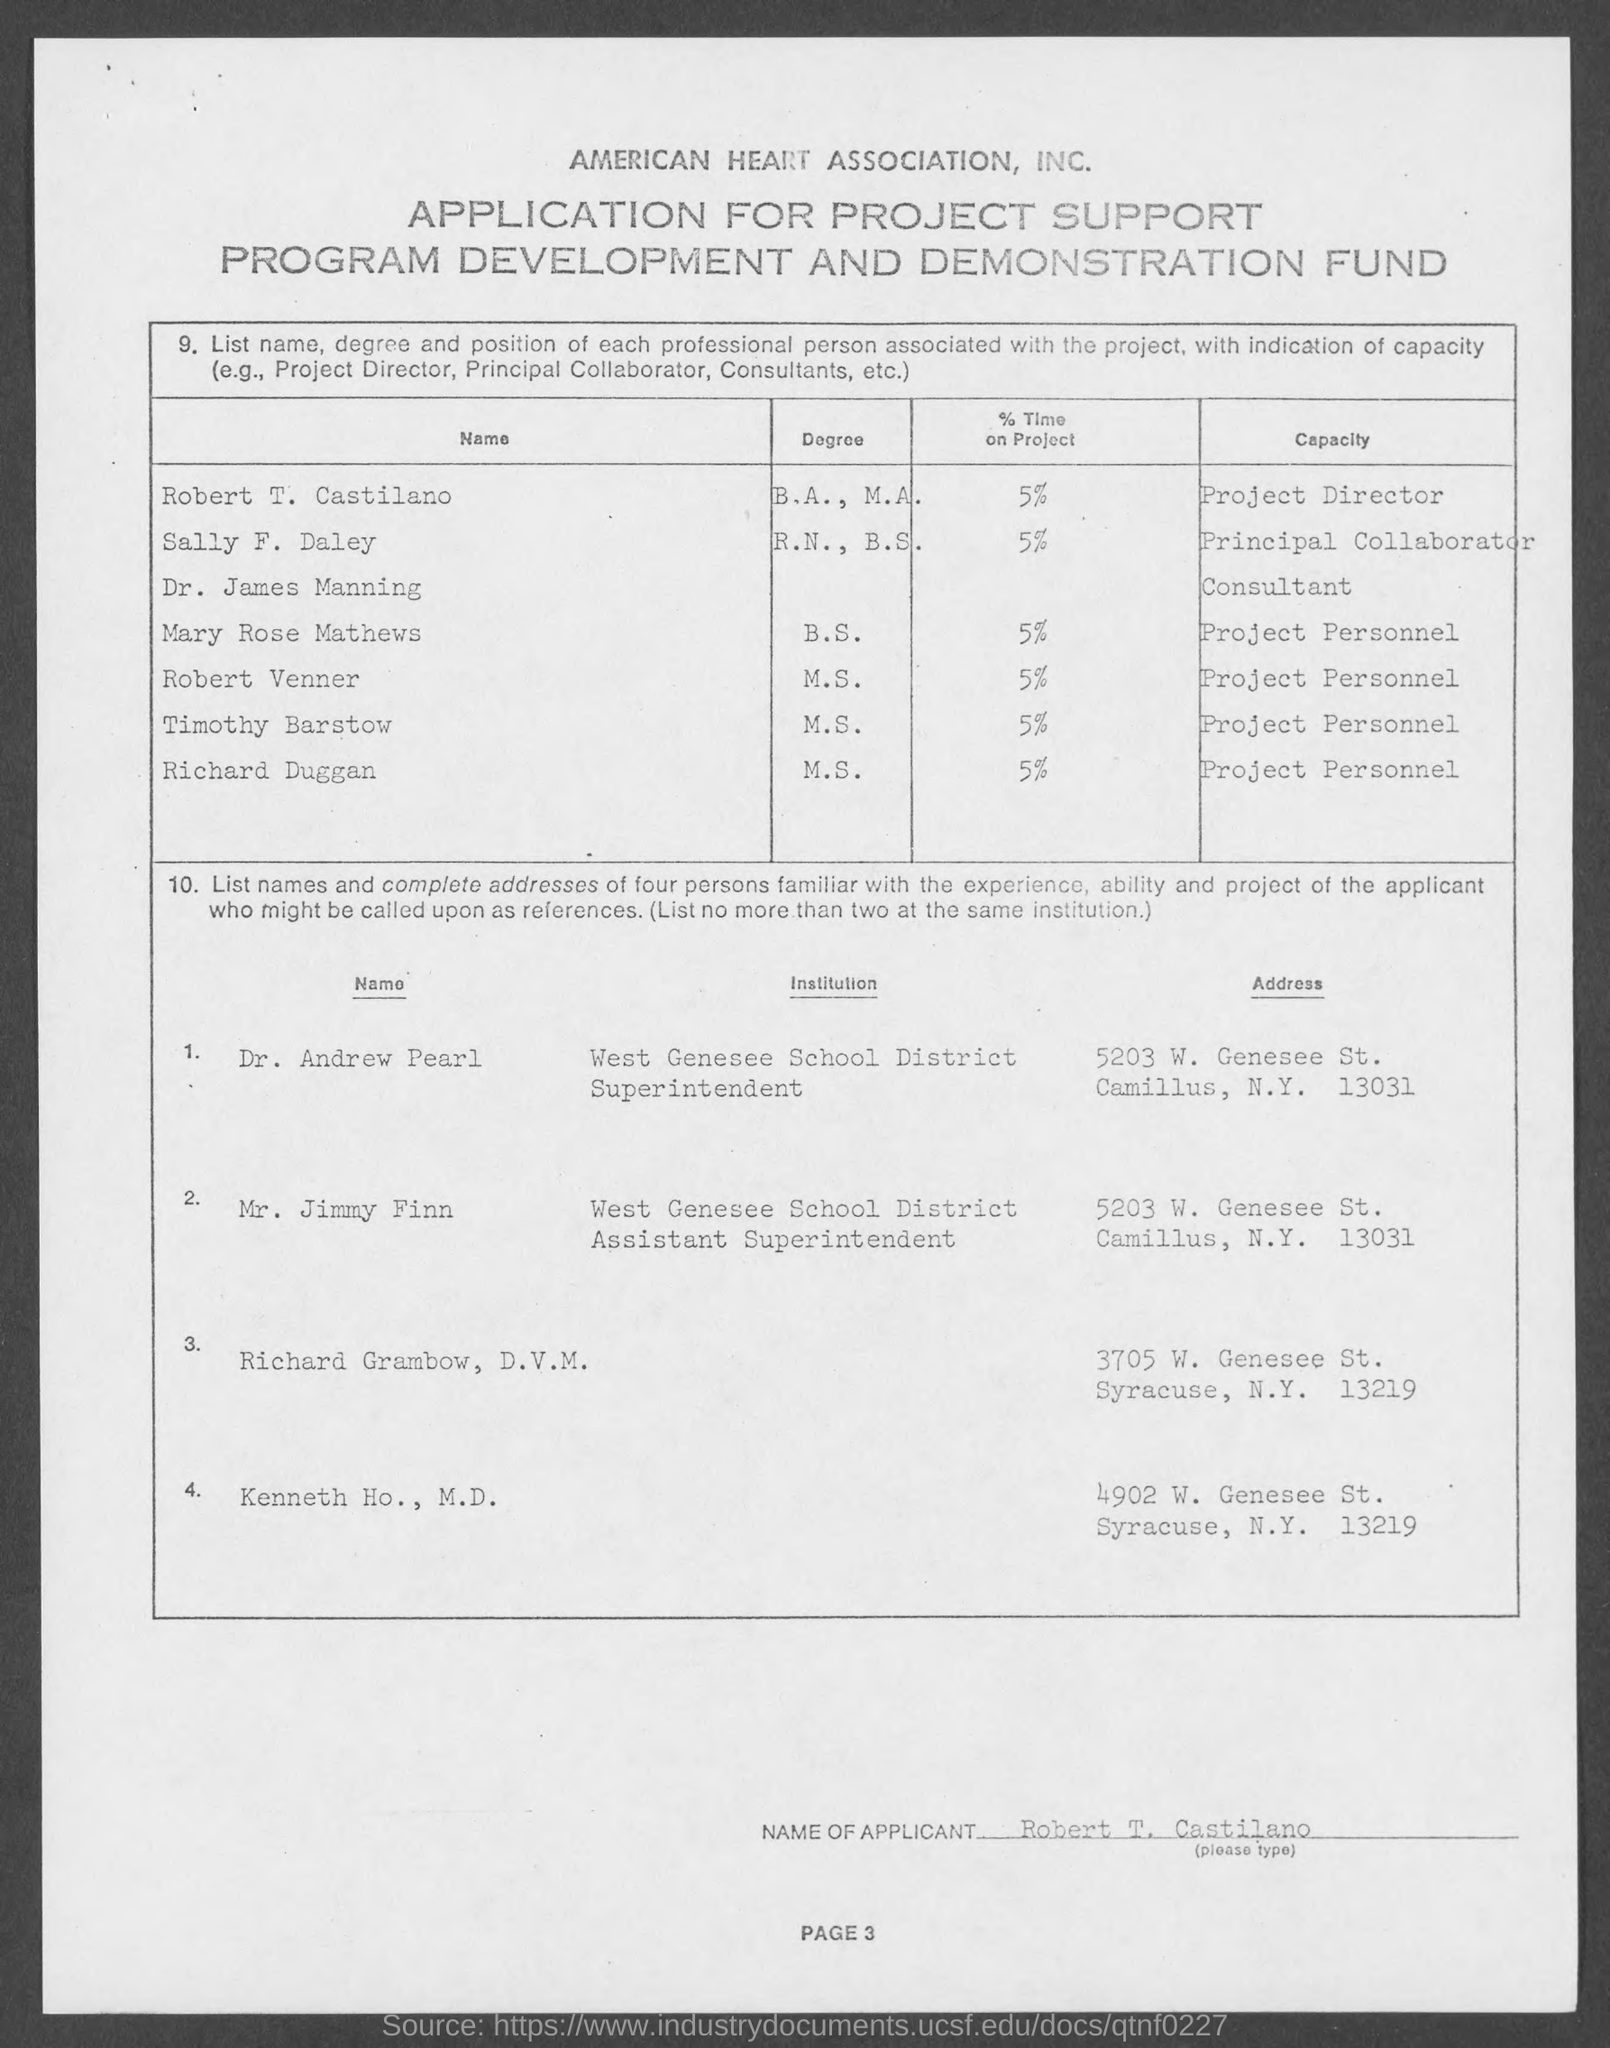Specify some key components in this picture. Robert Vener's project personnel capacity is currently unknown. Robert T. Castilano, the project director, mentioned the capacity of the given page. The capacity of Timothy Barstow, mentioned in the given page, is project personnel. Sally F. Daley is the principal collaborator with a capacity. Robert T. Castilano spent approximately 5% of the total time on the project. 